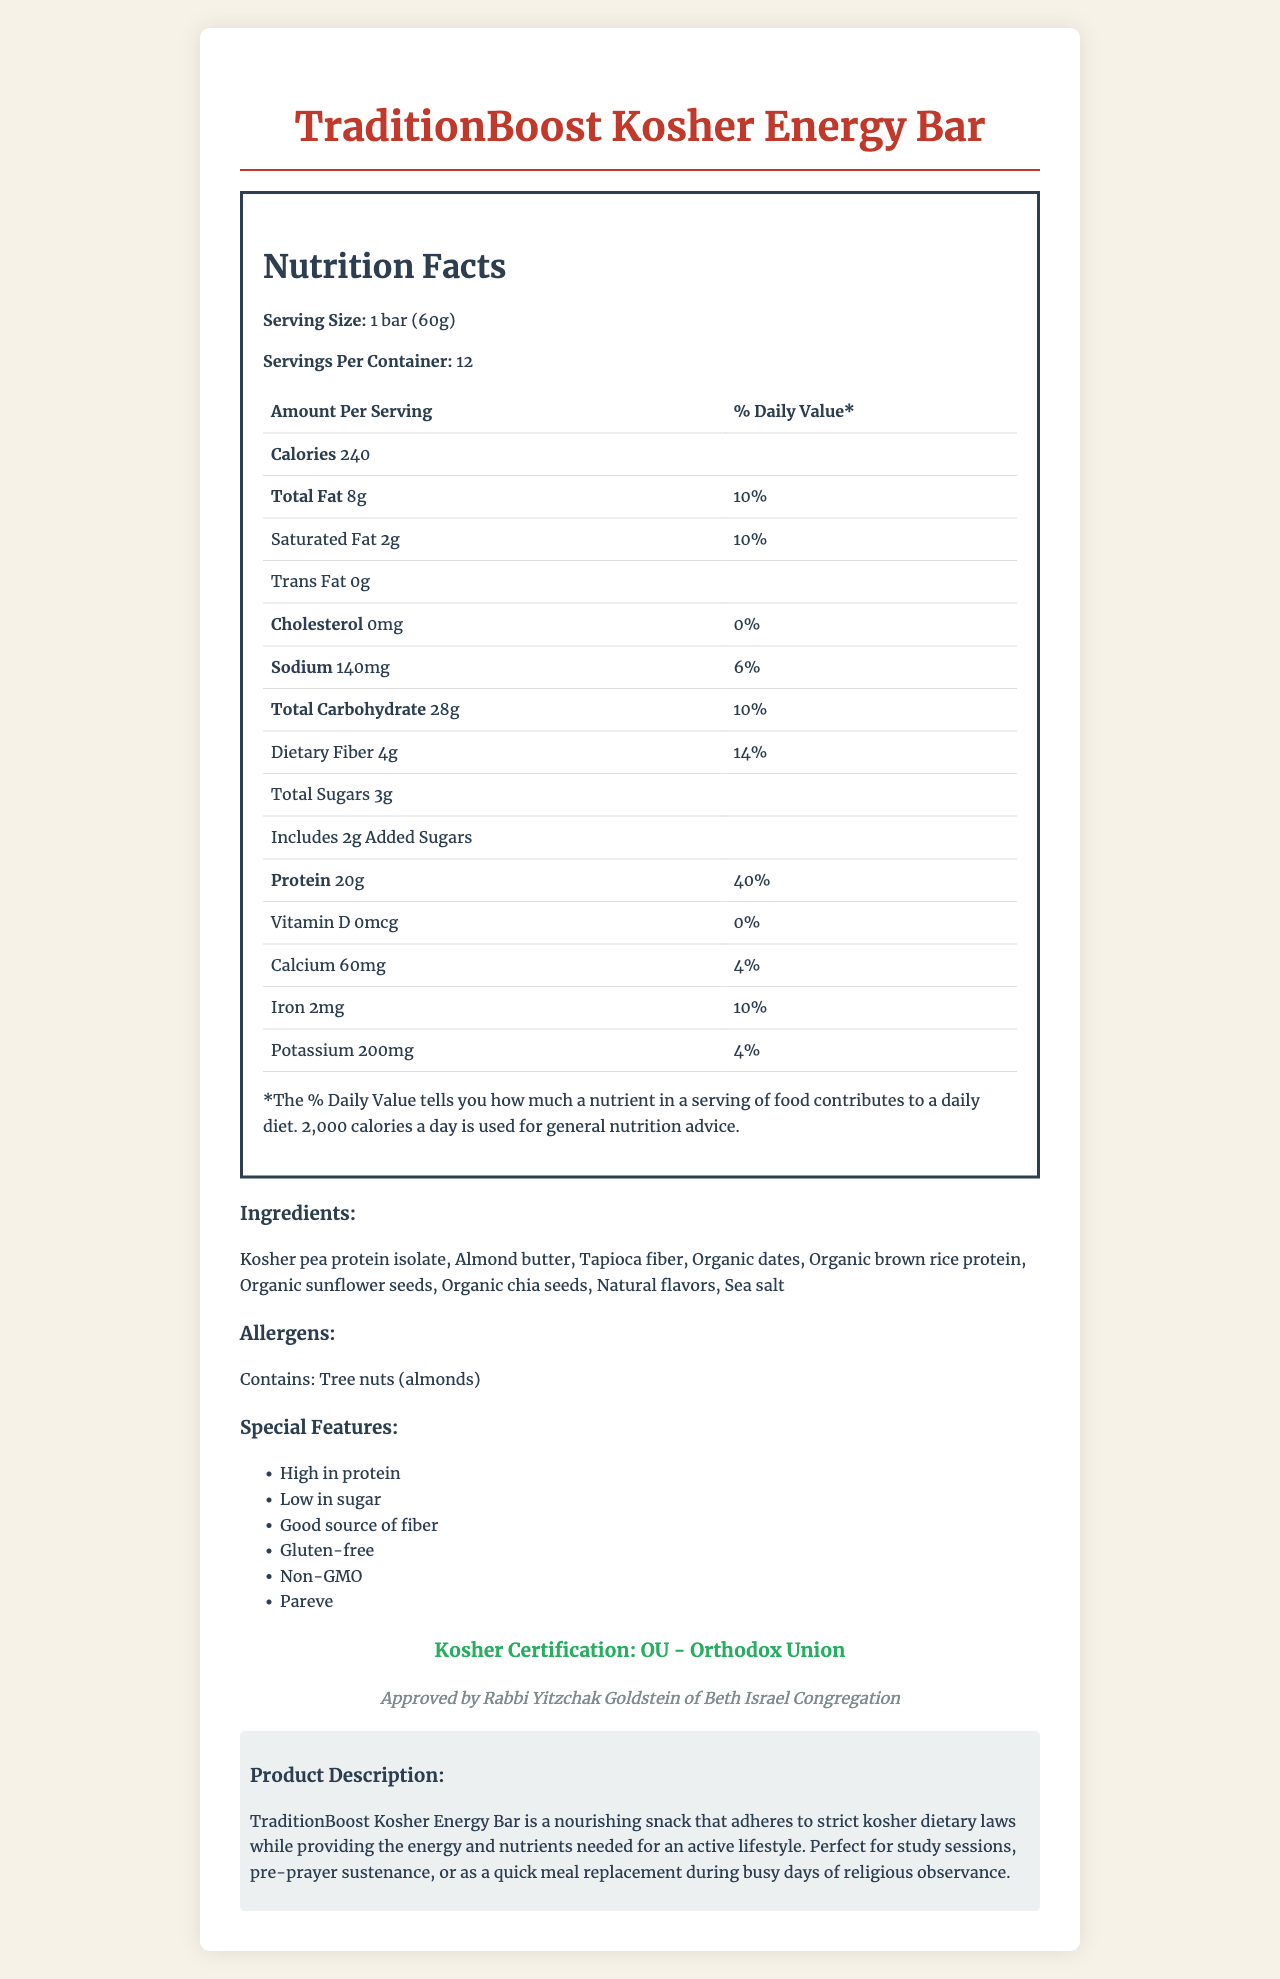what is the serving size? The serving size is provided at the beginning of the nutrition facts section: "Serving Size: 1 bar (60g)".
Answer: 1 bar (60g) how many servings are in a container? The number of servings per container is given as 12.
Answer: 12 what is the amount of protein per serving? The protein content per serving is listed as 20g in the nutrition facts.
Answer: 20g what is the main allergen in the energy bar? The allergens section specifies that the product contains tree nuts (almonds).
Answer: Tree nuts (almonds) which vitamin is not present in this energy bar? The nutrition facts state that Vitamin D is 0mcg, indicating it is not present.
Answer: Vitamin D which nutrient has the highest daily value percentage? A. Total Carbohydrate B. Protein C. Sodium D. Iron The daily value percentage of protein is 40%, which is the highest among the listed nutrients.
Answer: B. Protein how many grams of total sugars are there per serving? The amount of total sugars per serving is listed as 3g.
Answer: 3g how many grams of dietary fiber are in one serving? The nutritional information lists dietary fiber as 4g per serving.
Answer: 4g is this energy bar gluten-free? Under the special features, it is mentioned that the product is "Gluten-free".
Answer: Yes is the energy bar certified kosher by the Orthodox Union (OU)? The document states that the kosher certification is provided by the Orthodox Union (OU).
Answer: Yes describe the general purpose and key features of TraditionBoost Kosher Energy Bar. The product description highlights the energy bar’s purpose and key features, making it clear that it is both nutritious and adheres to kosher dietary laws.
Answer: TraditionBoost Kosher Energy Bar is designed to be a nourishing snack that adheres to strict kosher dietary laws, providing energy and nutrients for an active lifestyle. It boasts high protein content, low sugar, good sources of fiber, gluten-free, non-GMO ingredients, and is pareve. This makes it suitable for various occasions like study sessions, pre-prayer sustenance, or meal replacement during busy days of religious observance. who endorsed the kosher certification for this energy bar? The document mentions the rabbinic endorsement from Rabbi Yitzchak Goldstein of Beth Israel Congregation.
Answer: Rabbi Yitzchak Goldstein of Beth Israel Congregation what is the amount of potassium per serving? A. 100mg B. 200mg C. 150mg D. 250mg The nutrition facts list potassium content as 200mg per serving.
Answer: B. 200mg how many added sugars (in grams) does one serving contain? The nutrition facts indicate that there are 2g of added sugars in one serving.
Answer: 2g was the product description written in a way to appeal to Orthodox Jews? The description specifically mentions adhering to strict kosher dietary laws and mentions specific occasions such as pre-prayer sustenance and meal replacement during religious observance.
Answer: Yes is the bacteriological safety of this energy bar confirmed? The document does not provide any information about bacteriological safety.
Answer: Not enough information how much iron does each serving provide? The nutrition facts list iron content as 2mg per serving.
Answer: 2mg 